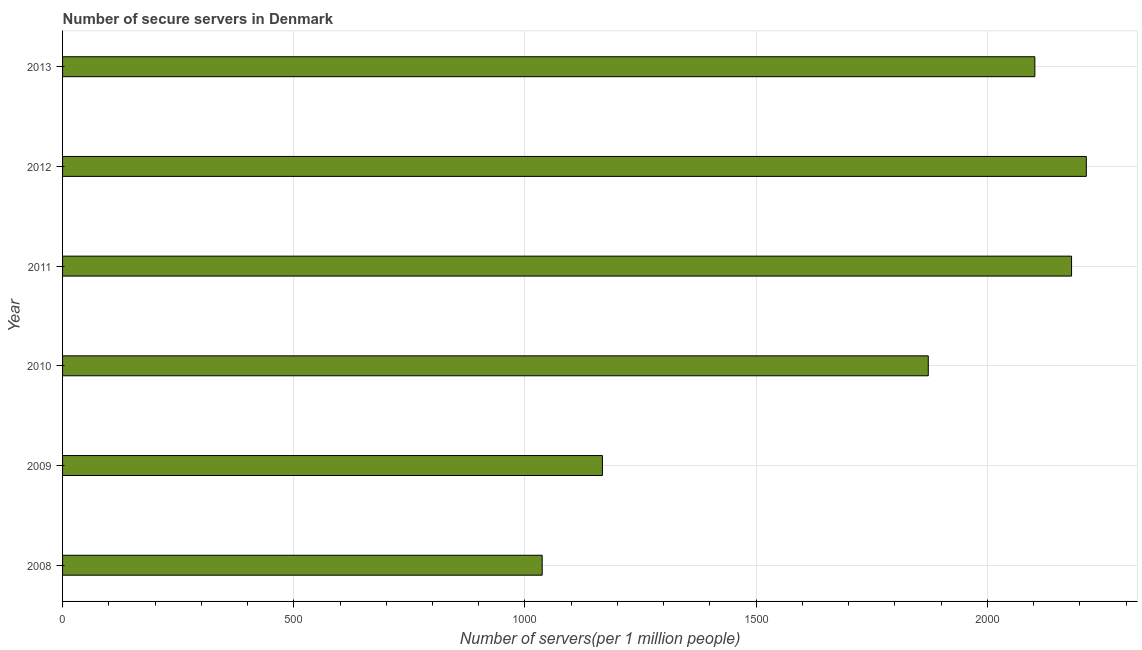Does the graph contain any zero values?
Offer a terse response. No. Does the graph contain grids?
Provide a succinct answer. Yes. What is the title of the graph?
Your response must be concise. Number of secure servers in Denmark. What is the label or title of the X-axis?
Provide a short and direct response. Number of servers(per 1 million people). What is the label or title of the Y-axis?
Your answer should be compact. Year. What is the number of secure internet servers in 2009?
Make the answer very short. 1167.46. Across all years, what is the maximum number of secure internet servers?
Your answer should be very brief. 2213.87. Across all years, what is the minimum number of secure internet servers?
Provide a short and direct response. 1037.2. What is the sum of the number of secure internet servers?
Your answer should be very brief. 1.06e+04. What is the difference between the number of secure internet servers in 2008 and 2009?
Your answer should be very brief. -130.26. What is the average number of secure internet servers per year?
Keep it short and to the point. 1762.55. What is the median number of secure internet servers?
Your answer should be very brief. 1987.37. In how many years, is the number of secure internet servers greater than 1000 ?
Provide a succinct answer. 6. Do a majority of the years between 2008 and 2013 (inclusive) have number of secure internet servers greater than 600 ?
Your answer should be very brief. Yes. What is the ratio of the number of secure internet servers in 2011 to that in 2013?
Make the answer very short. 1.04. Is the number of secure internet servers in 2009 less than that in 2010?
Your answer should be very brief. Yes. What is the difference between the highest and the second highest number of secure internet servers?
Provide a succinct answer. 31.86. Is the sum of the number of secure internet servers in 2009 and 2013 greater than the maximum number of secure internet servers across all years?
Your response must be concise. Yes. What is the difference between the highest and the lowest number of secure internet servers?
Your answer should be compact. 1176.66. How many bars are there?
Provide a short and direct response. 6. How many years are there in the graph?
Ensure brevity in your answer.  6. What is the difference between two consecutive major ticks on the X-axis?
Your response must be concise. 500. What is the Number of servers(per 1 million people) of 2008?
Your response must be concise. 1037.2. What is the Number of servers(per 1 million people) of 2009?
Provide a succinct answer. 1167.46. What is the Number of servers(per 1 million people) of 2010?
Provide a succinct answer. 1872.13. What is the Number of servers(per 1 million people) in 2011?
Your answer should be compact. 2182. What is the Number of servers(per 1 million people) in 2012?
Your response must be concise. 2213.87. What is the Number of servers(per 1 million people) in 2013?
Your answer should be very brief. 2102.61. What is the difference between the Number of servers(per 1 million people) in 2008 and 2009?
Ensure brevity in your answer.  -130.26. What is the difference between the Number of servers(per 1 million people) in 2008 and 2010?
Keep it short and to the point. -834.93. What is the difference between the Number of servers(per 1 million people) in 2008 and 2011?
Your response must be concise. -1144.8. What is the difference between the Number of servers(per 1 million people) in 2008 and 2012?
Your answer should be very brief. -1176.66. What is the difference between the Number of servers(per 1 million people) in 2008 and 2013?
Provide a succinct answer. -1065.4. What is the difference between the Number of servers(per 1 million people) in 2009 and 2010?
Your response must be concise. -704.67. What is the difference between the Number of servers(per 1 million people) in 2009 and 2011?
Ensure brevity in your answer.  -1014.54. What is the difference between the Number of servers(per 1 million people) in 2009 and 2012?
Give a very brief answer. -1046.41. What is the difference between the Number of servers(per 1 million people) in 2009 and 2013?
Provide a short and direct response. -935.15. What is the difference between the Number of servers(per 1 million people) in 2010 and 2011?
Your answer should be compact. -309.87. What is the difference between the Number of servers(per 1 million people) in 2010 and 2012?
Provide a succinct answer. -341.73. What is the difference between the Number of servers(per 1 million people) in 2010 and 2013?
Keep it short and to the point. -230.47. What is the difference between the Number of servers(per 1 million people) in 2011 and 2012?
Offer a very short reply. -31.87. What is the difference between the Number of servers(per 1 million people) in 2011 and 2013?
Provide a succinct answer. 79.39. What is the difference between the Number of servers(per 1 million people) in 2012 and 2013?
Make the answer very short. 111.26. What is the ratio of the Number of servers(per 1 million people) in 2008 to that in 2009?
Offer a very short reply. 0.89. What is the ratio of the Number of servers(per 1 million people) in 2008 to that in 2010?
Provide a short and direct response. 0.55. What is the ratio of the Number of servers(per 1 million people) in 2008 to that in 2011?
Make the answer very short. 0.47. What is the ratio of the Number of servers(per 1 million people) in 2008 to that in 2012?
Your answer should be very brief. 0.47. What is the ratio of the Number of servers(per 1 million people) in 2008 to that in 2013?
Ensure brevity in your answer.  0.49. What is the ratio of the Number of servers(per 1 million people) in 2009 to that in 2010?
Your answer should be very brief. 0.62. What is the ratio of the Number of servers(per 1 million people) in 2009 to that in 2011?
Give a very brief answer. 0.54. What is the ratio of the Number of servers(per 1 million people) in 2009 to that in 2012?
Give a very brief answer. 0.53. What is the ratio of the Number of servers(per 1 million people) in 2009 to that in 2013?
Your response must be concise. 0.56. What is the ratio of the Number of servers(per 1 million people) in 2010 to that in 2011?
Your answer should be very brief. 0.86. What is the ratio of the Number of servers(per 1 million people) in 2010 to that in 2012?
Your answer should be compact. 0.85. What is the ratio of the Number of servers(per 1 million people) in 2010 to that in 2013?
Provide a short and direct response. 0.89. What is the ratio of the Number of servers(per 1 million people) in 2011 to that in 2013?
Ensure brevity in your answer.  1.04. What is the ratio of the Number of servers(per 1 million people) in 2012 to that in 2013?
Your answer should be compact. 1.05. 